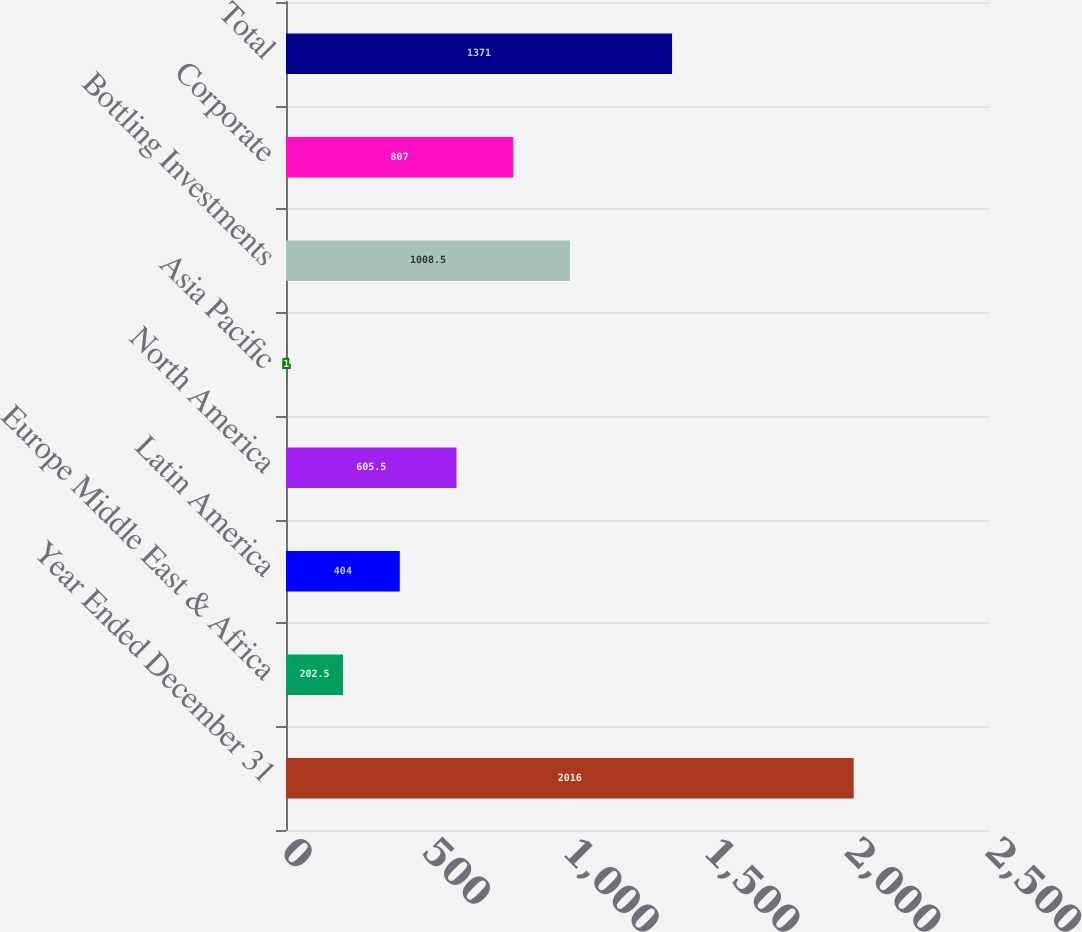Convert chart. <chart><loc_0><loc_0><loc_500><loc_500><bar_chart><fcel>Year Ended December 31<fcel>Europe Middle East & Africa<fcel>Latin America<fcel>North America<fcel>Asia Pacific<fcel>Bottling Investments<fcel>Corporate<fcel>Total<nl><fcel>2016<fcel>202.5<fcel>404<fcel>605.5<fcel>1<fcel>1008.5<fcel>807<fcel>1371<nl></chart> 